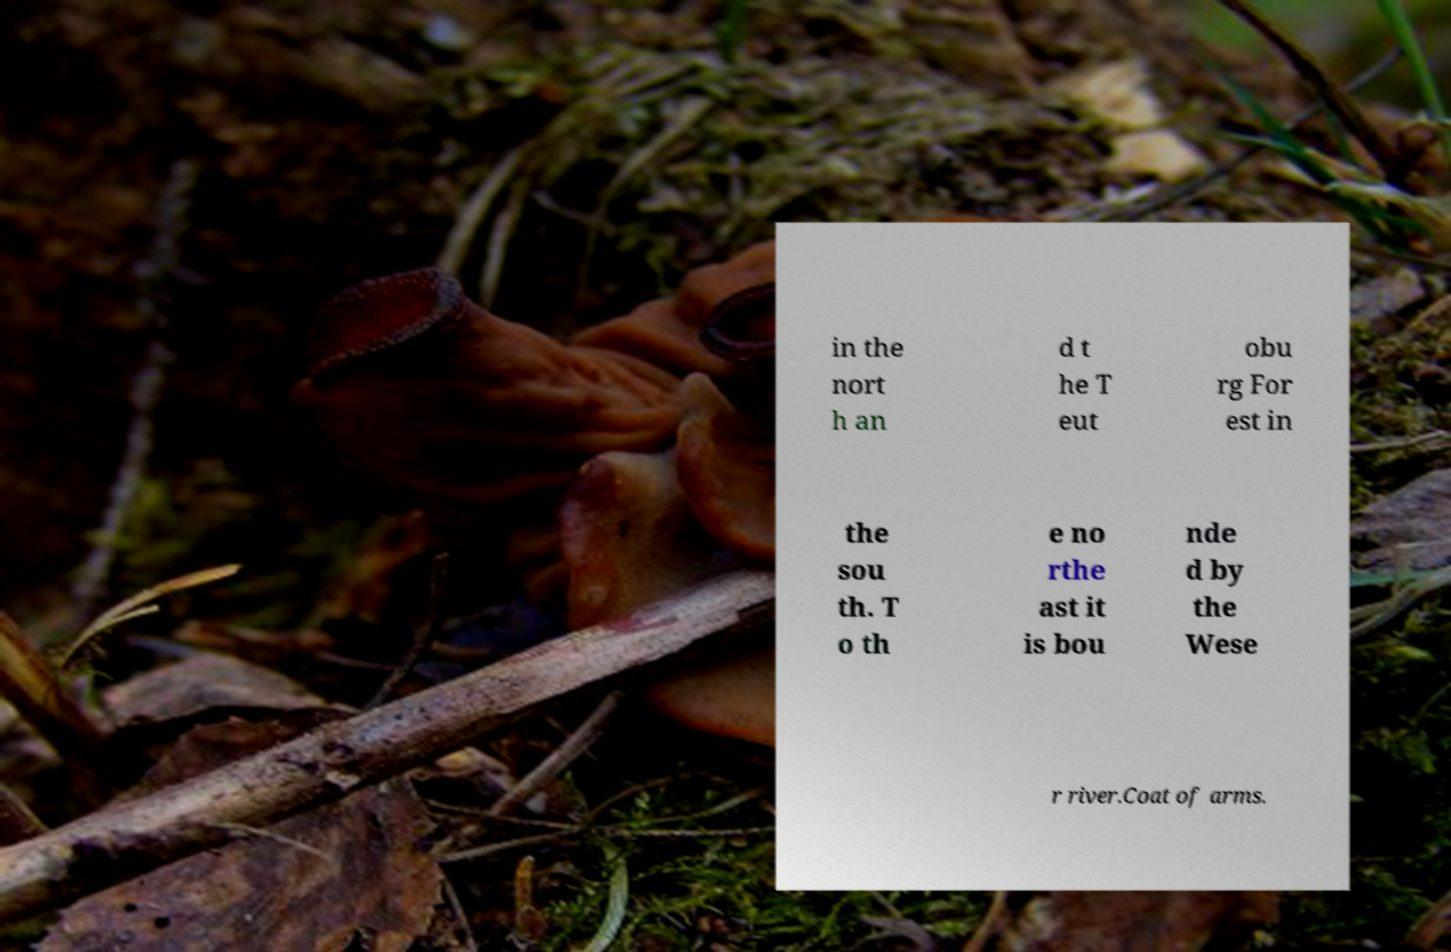Can you accurately transcribe the text from the provided image for me? in the nort h an d t he T eut obu rg For est in the sou th. T o th e no rthe ast it is bou nde d by the Wese r river.Coat of arms. 